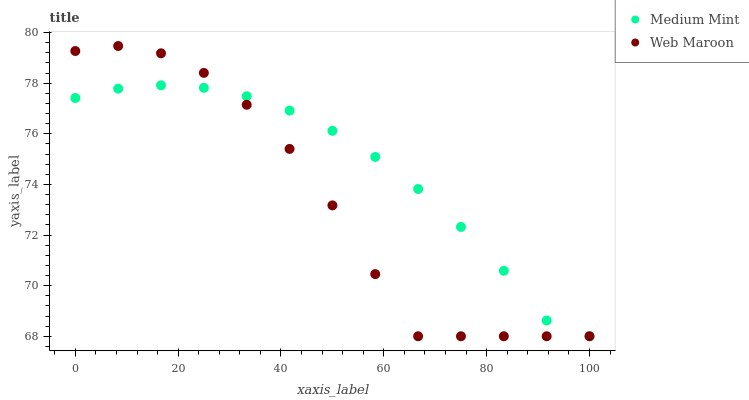Does Web Maroon have the minimum area under the curve?
Answer yes or no. Yes. Does Medium Mint have the maximum area under the curve?
Answer yes or no. Yes. Does Web Maroon have the maximum area under the curve?
Answer yes or no. No. Is Medium Mint the smoothest?
Answer yes or no. Yes. Is Web Maroon the roughest?
Answer yes or no. Yes. Is Web Maroon the smoothest?
Answer yes or no. No. Does Medium Mint have the lowest value?
Answer yes or no. Yes. Does Web Maroon have the highest value?
Answer yes or no. Yes. Does Web Maroon intersect Medium Mint?
Answer yes or no. Yes. Is Web Maroon less than Medium Mint?
Answer yes or no. No. Is Web Maroon greater than Medium Mint?
Answer yes or no. No. 